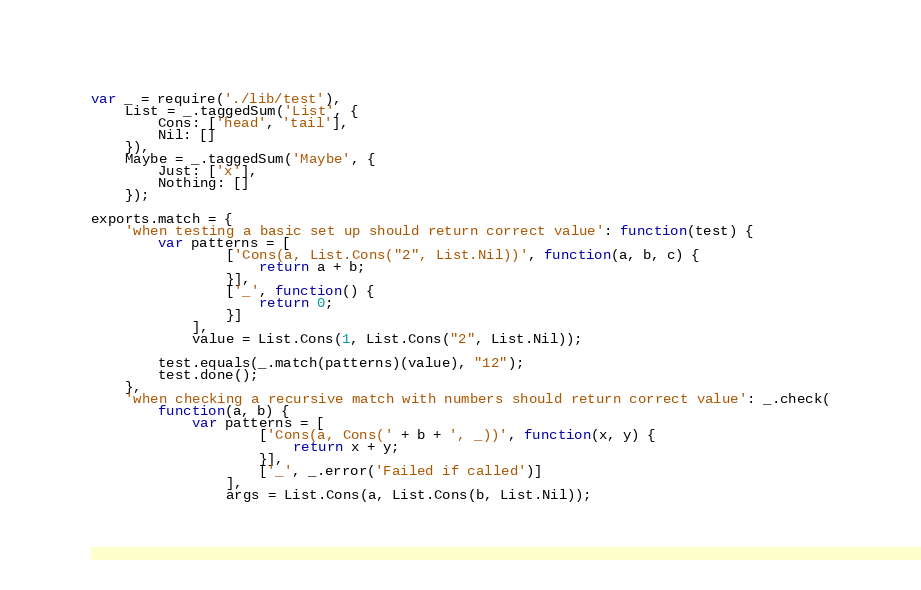<code> <loc_0><loc_0><loc_500><loc_500><_JavaScript_>var _ = require('./lib/test'),
    List = _.taggedSum('List', {
        Cons: ['head', 'tail'],
        Nil: []
    }),
    Maybe = _.taggedSum('Maybe', {
        Just: ['x'],
        Nothing: []
    });

exports.match = {
    'when testing a basic set up should return correct value': function(test) {
        var patterns = [
                ['Cons(a, List.Cons("2", List.Nil))', function(a, b, c) {
                    return a + b;
                }],
                ['_', function() {
                    return 0;
                }]
            ],
            value = List.Cons(1, List.Cons("2", List.Nil));

        test.equals(_.match(patterns)(value), "12");
        test.done();
    },
    'when checking a recursive match with numbers should return correct value': _.check(
        function(a, b) {
            var patterns = [
                    ['Cons(a, Cons(' + b + ', _))', function(x, y) {
                        return x + y;
                    }],
                    ['_', _.error('Failed if called')]
                ],
                args = List.Cons(a, List.Cons(b, List.Nil));
</code> 